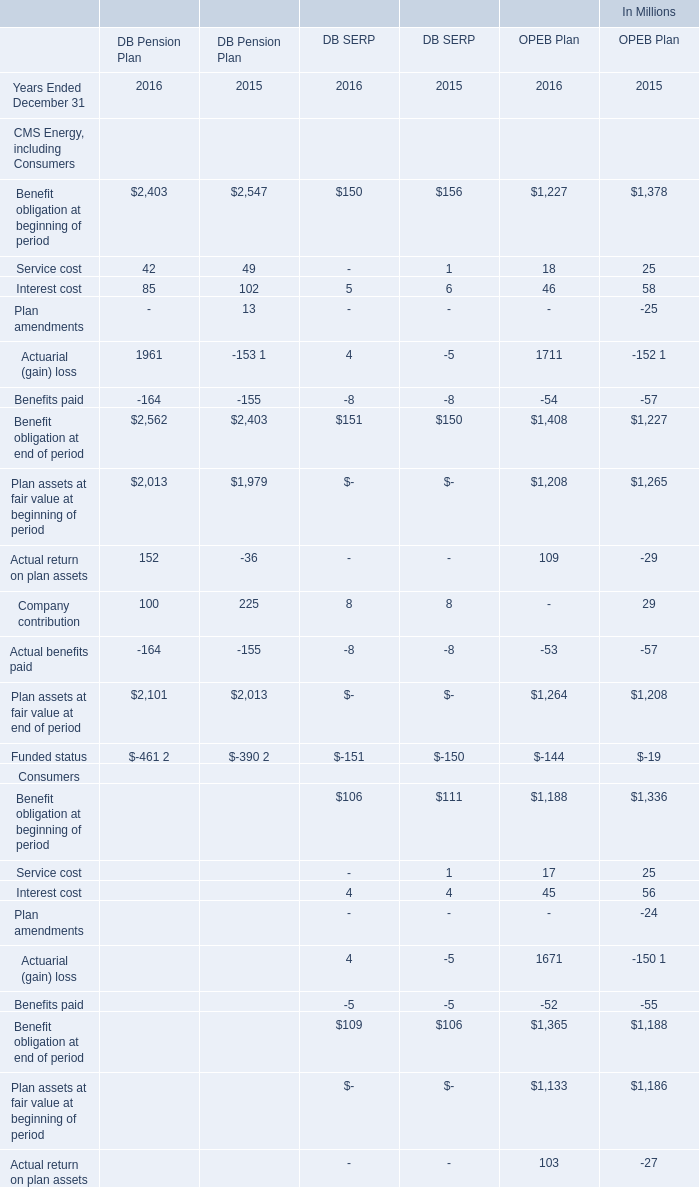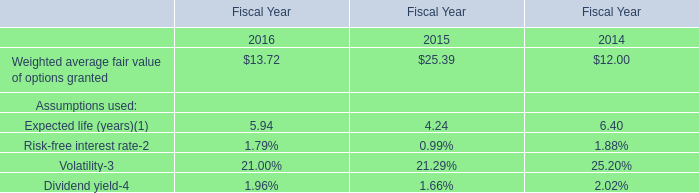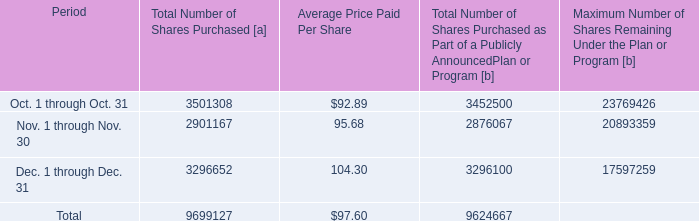What's the sum of all DB Pension Plan that are positive in 2016? (in million) 
Computations: ((((((2403 + 42) + 85) + 1961) + 2013) + 152) + 100)
Answer: 6756.0. 